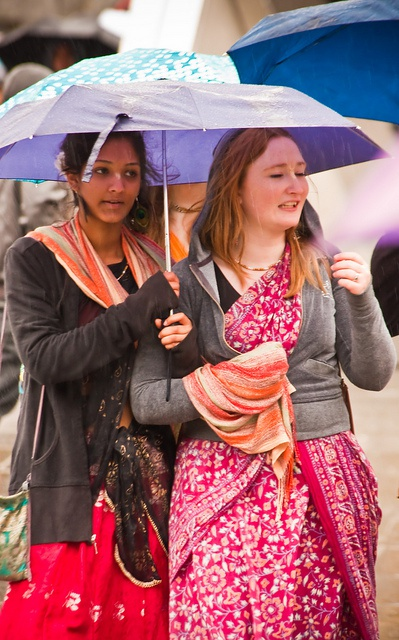Describe the objects in this image and their specific colors. I can see people in gray, lightpink, brown, and maroon tones, people in gray, black, maroon, and red tones, umbrella in gray, lavender, violet, and purple tones, umbrella in gray, blue, navy, and darkblue tones, and umbrella in gray, white, lightblue, and turquoise tones in this image. 